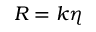Convert formula to latex. <formula><loc_0><loc_0><loc_500><loc_500>R = k \eta</formula> 